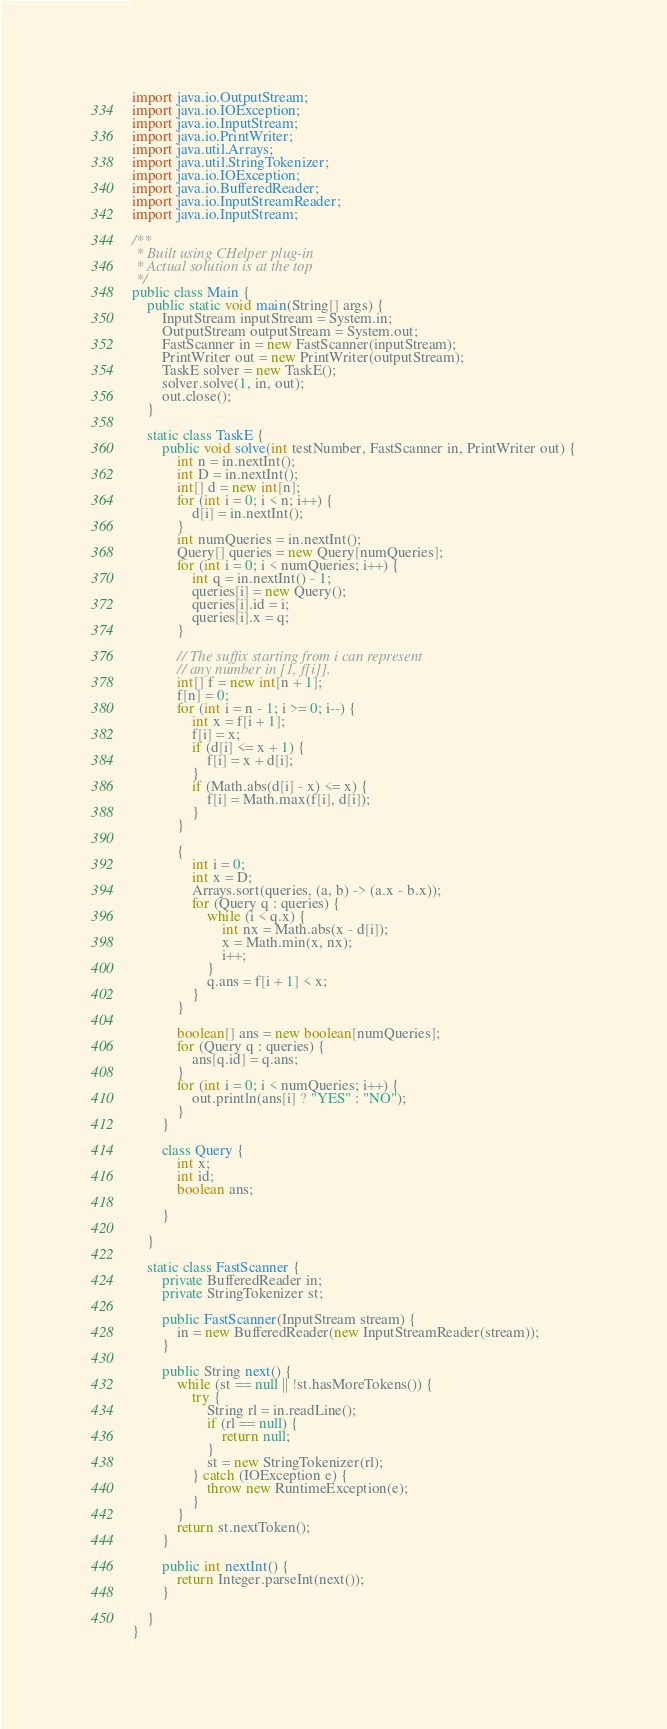Convert code to text. <code><loc_0><loc_0><loc_500><loc_500><_Java_>import java.io.OutputStream;
import java.io.IOException;
import java.io.InputStream;
import java.io.PrintWriter;
import java.util.Arrays;
import java.util.StringTokenizer;
import java.io.IOException;
import java.io.BufferedReader;
import java.io.InputStreamReader;
import java.io.InputStream;

/**
 * Built using CHelper plug-in
 * Actual solution is at the top
 */
public class Main {
	public static void main(String[] args) {
		InputStream inputStream = System.in;
		OutputStream outputStream = System.out;
		FastScanner in = new FastScanner(inputStream);
		PrintWriter out = new PrintWriter(outputStream);
		TaskE solver = new TaskE();
		solver.solve(1, in, out);
		out.close();
	}

	static class TaskE {
		public void solve(int testNumber, FastScanner in, PrintWriter out) {
			int n = in.nextInt();
			int D = in.nextInt();
			int[] d = new int[n];
			for (int i = 0; i < n; i++) {
				d[i] = in.nextInt();
			}
			int numQueries = in.nextInt();
			Query[] queries = new Query[numQueries];
			for (int i = 0; i < numQueries; i++) {
				int q = in.nextInt() - 1;
				queries[i] = new Query();
				queries[i].id = i;
				queries[i].x = q;
			}

			// The suffix starting from i can represent
			// any number in [1, f[i]].
			int[] f = new int[n + 1];
			f[n] = 0;
			for (int i = n - 1; i >= 0; i--) {
				int x = f[i + 1];
				f[i] = x;
				if (d[i] <= x + 1) {
					f[i] = x + d[i];
				}
				if (Math.abs(d[i] - x) <= x) {
					f[i] = Math.max(f[i], d[i]);
				}
			}

			{
				int i = 0;
				int x = D;
				Arrays.sort(queries, (a, b) -> (a.x - b.x));
				for (Query q : queries) {
					while (i < q.x) {
						int nx = Math.abs(x - d[i]);
						x = Math.min(x, nx);
						i++;
					}
					q.ans = f[i + 1] < x;
				}
			}

			boolean[] ans = new boolean[numQueries];
			for (Query q : queries) {
				ans[q.id] = q.ans;
			}
			for (int i = 0; i < numQueries; i++) {
				out.println(ans[i] ? "YES" : "NO");
			}
		}

		class Query {
			int x;
			int id;
			boolean ans;

		}

	}

	static class FastScanner {
		private BufferedReader in;
		private StringTokenizer st;

		public FastScanner(InputStream stream) {
			in = new BufferedReader(new InputStreamReader(stream));
		}

		public String next() {
			while (st == null || !st.hasMoreTokens()) {
				try {
					String rl = in.readLine();
					if (rl == null) {
						return null;
					}
					st = new StringTokenizer(rl);
				} catch (IOException e) {
					throw new RuntimeException(e);
				}
			}
			return st.nextToken();
		}

		public int nextInt() {
			return Integer.parseInt(next());
		}

	}
}

</code> 